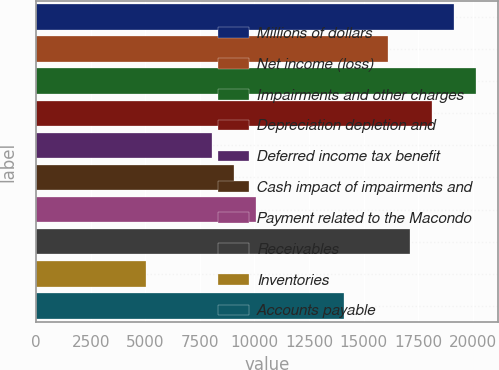Convert chart to OTSL. <chart><loc_0><loc_0><loc_500><loc_500><bar_chart><fcel>Millions of dollars<fcel>Net income (loss)<fcel>Impairments and other charges<fcel>Depreciation depletion and<fcel>Deferred income tax benefit<fcel>Cash impact of impairments and<fcel>Payment related to the Macondo<fcel>Receivables<fcel>Inventories<fcel>Accounts payable<nl><fcel>19139.1<fcel>16118.4<fcel>20146<fcel>18132.2<fcel>8063.2<fcel>9070.1<fcel>10077<fcel>17125.3<fcel>5042.5<fcel>14104.6<nl></chart> 